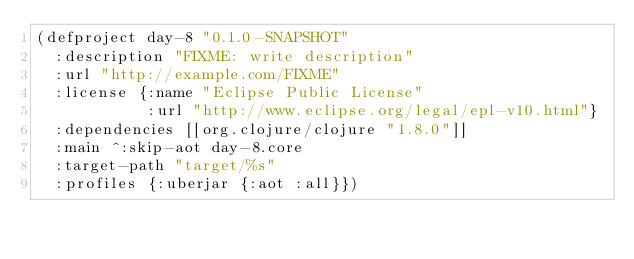Convert code to text. <code><loc_0><loc_0><loc_500><loc_500><_Clojure_>(defproject day-8 "0.1.0-SNAPSHOT"
  :description "FIXME: write description"
  :url "http://example.com/FIXME"
  :license {:name "Eclipse Public License"
            :url "http://www.eclipse.org/legal/epl-v10.html"}
  :dependencies [[org.clojure/clojure "1.8.0"]]
  :main ^:skip-aot day-8.core
  :target-path "target/%s"
  :profiles {:uberjar {:aot :all}})
</code> 